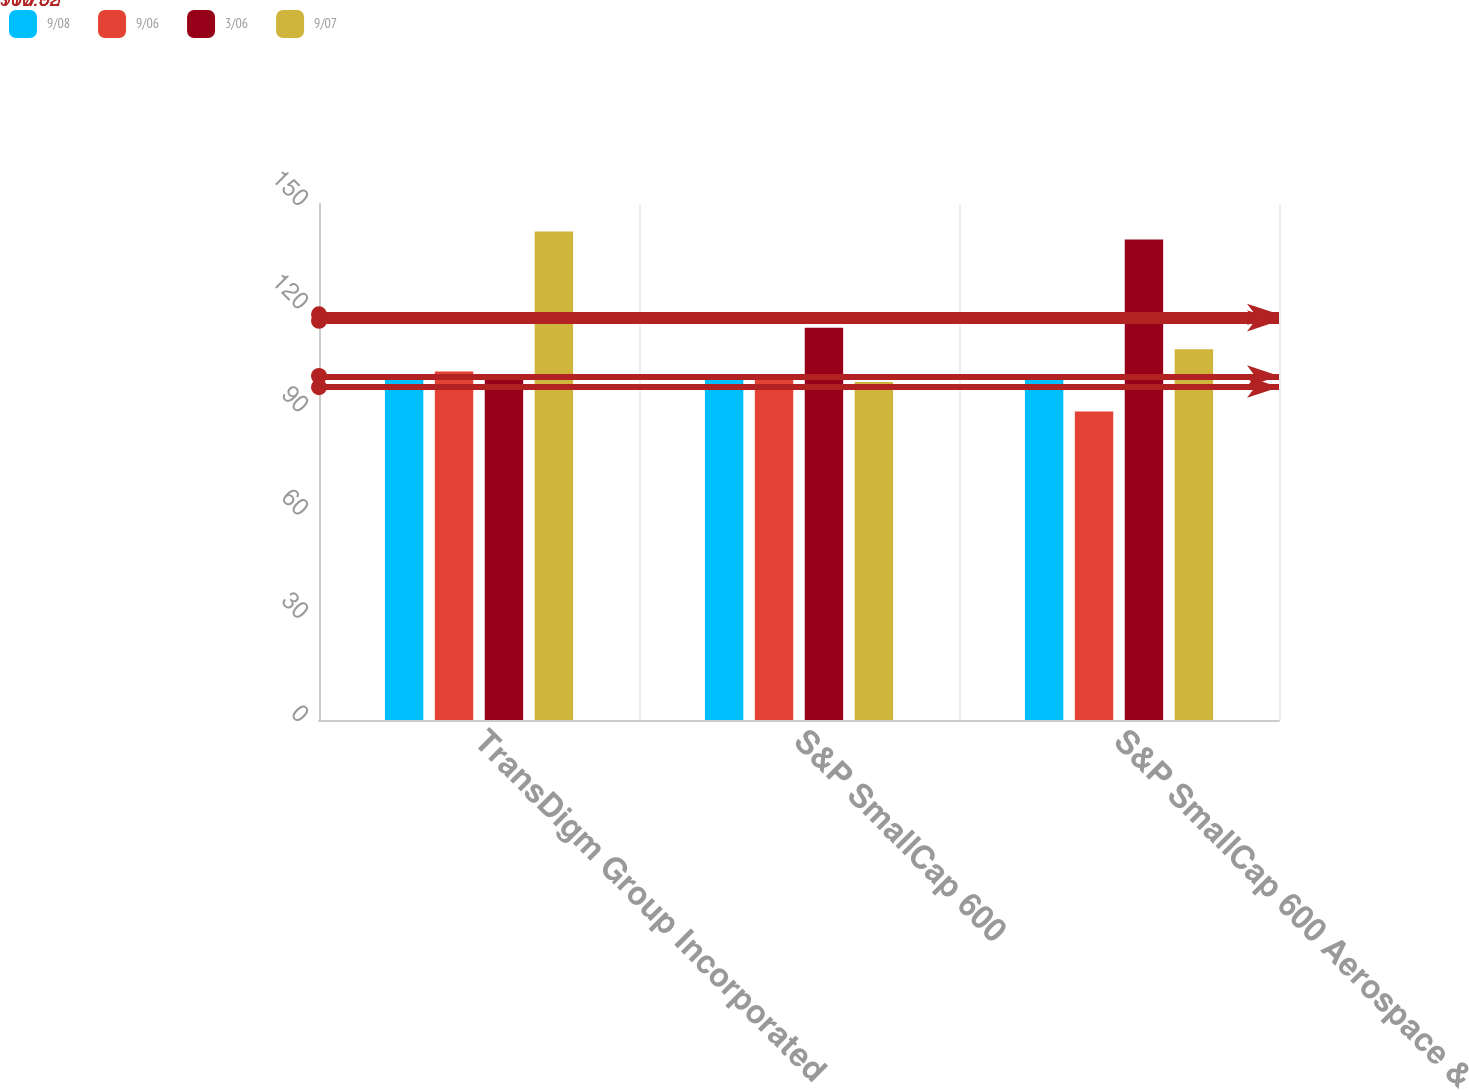Convert chart to OTSL. <chart><loc_0><loc_0><loc_500><loc_500><stacked_bar_chart><ecel><fcel>TransDigm Group Incorporated<fcel>S&P SmallCap 600<fcel>S&P SmallCap 600 Aerospace &<nl><fcel>9/08<fcel>100<fcel>100<fcel>100<nl><fcel>9/06<fcel>101.33<fcel>99.24<fcel>89.68<nl><fcel>3/06<fcel>100<fcel>114.06<fcel>139.7<nl><fcel>9/07<fcel>142.03<fcel>98.29<fcel>107.76<nl></chart> 